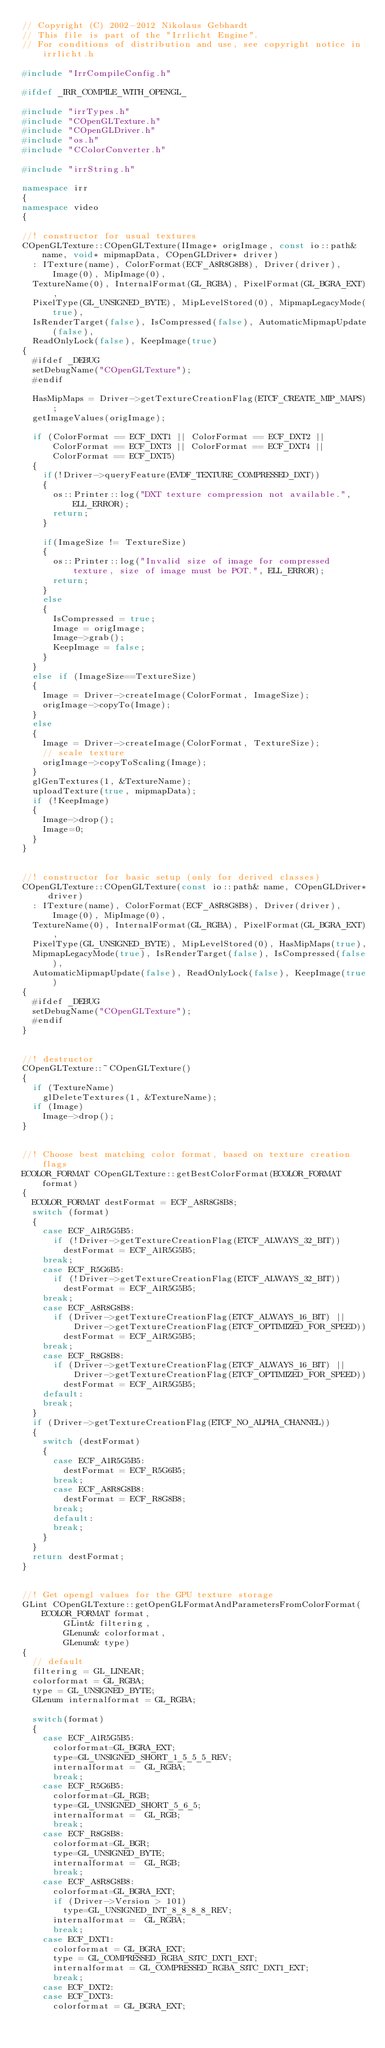<code> <loc_0><loc_0><loc_500><loc_500><_C++_>// Copyright (C) 2002-2012 Nikolaus Gebhardt
// This file is part of the "Irrlicht Engine".
// For conditions of distribution and use, see copyright notice in irrlicht.h

#include "IrrCompileConfig.h"

#ifdef _IRR_COMPILE_WITH_OPENGL_

#include "irrTypes.h"
#include "COpenGLTexture.h"
#include "COpenGLDriver.h"
#include "os.h"
#include "CColorConverter.h"

#include "irrString.h"

namespace irr
{
namespace video
{

//! constructor for usual textures
COpenGLTexture::COpenGLTexture(IImage* origImage, const io::path& name, void* mipmapData, COpenGLDriver* driver)
	: ITexture(name), ColorFormat(ECF_A8R8G8B8), Driver(driver), Image(0), MipImage(0),
	TextureName(0), InternalFormat(GL_RGBA), PixelFormat(GL_BGRA_EXT),
	PixelType(GL_UNSIGNED_BYTE), MipLevelStored(0), MipmapLegacyMode(true),
	IsRenderTarget(false), IsCompressed(false), AutomaticMipmapUpdate(false),
	ReadOnlyLock(false), KeepImage(true)
{
	#ifdef _DEBUG
	setDebugName("COpenGLTexture");
	#endif

	HasMipMaps = Driver->getTextureCreationFlag(ETCF_CREATE_MIP_MAPS);
	getImageValues(origImage);

	if (ColorFormat == ECF_DXT1 || ColorFormat == ECF_DXT2 || ColorFormat == ECF_DXT3 || ColorFormat == ECF_DXT4 || ColorFormat == ECF_DXT5)
	{
		if(!Driver->queryFeature(EVDF_TEXTURE_COMPRESSED_DXT))
		{
			os::Printer::log("DXT texture compression not available.", ELL_ERROR);
			return;
		}

		if(ImageSize != TextureSize)
		{
			os::Printer::log("Invalid size of image for compressed texture, size of image must be POT.", ELL_ERROR);
			return;
		}
		else
		{
			IsCompressed = true;
			Image = origImage;
			Image->grab();
			KeepImage = false;
		}
	}
	else if (ImageSize==TextureSize)
	{
		Image = Driver->createImage(ColorFormat, ImageSize);
		origImage->copyTo(Image);
	}
	else
	{
		Image = Driver->createImage(ColorFormat, TextureSize);
		// scale texture
		origImage->copyToScaling(Image);
	}
	glGenTextures(1, &TextureName);
	uploadTexture(true, mipmapData);
	if (!KeepImage)
	{
		Image->drop();
		Image=0;
	}
}


//! constructor for basic setup (only for derived classes)
COpenGLTexture::COpenGLTexture(const io::path& name, COpenGLDriver* driver)
	: ITexture(name), ColorFormat(ECF_A8R8G8B8), Driver(driver), Image(0), MipImage(0),
	TextureName(0), InternalFormat(GL_RGBA), PixelFormat(GL_BGRA_EXT),
	PixelType(GL_UNSIGNED_BYTE), MipLevelStored(0), HasMipMaps(true),
	MipmapLegacyMode(true), IsRenderTarget(false), IsCompressed(false),
	AutomaticMipmapUpdate(false), ReadOnlyLock(false), KeepImage(true)
{
	#ifdef _DEBUG
	setDebugName("COpenGLTexture");
	#endif
}


//! destructor
COpenGLTexture::~COpenGLTexture()
{
	if (TextureName)
		glDeleteTextures(1, &TextureName);
	if (Image)
		Image->drop();
}


//! Choose best matching color format, based on texture creation flags
ECOLOR_FORMAT COpenGLTexture::getBestColorFormat(ECOLOR_FORMAT format)
{
	ECOLOR_FORMAT destFormat = ECF_A8R8G8B8;
	switch (format)
	{
		case ECF_A1R5G5B5:
			if (!Driver->getTextureCreationFlag(ETCF_ALWAYS_32_BIT))
				destFormat = ECF_A1R5G5B5;
		break;
		case ECF_R5G6B5:
			if (!Driver->getTextureCreationFlag(ETCF_ALWAYS_32_BIT))
				destFormat = ECF_A1R5G5B5;
		break;
		case ECF_A8R8G8B8:
			if (Driver->getTextureCreationFlag(ETCF_ALWAYS_16_BIT) ||
					Driver->getTextureCreationFlag(ETCF_OPTIMIZED_FOR_SPEED))
				destFormat = ECF_A1R5G5B5;
		break;
		case ECF_R8G8B8:
			if (Driver->getTextureCreationFlag(ETCF_ALWAYS_16_BIT) ||
					Driver->getTextureCreationFlag(ETCF_OPTIMIZED_FOR_SPEED))
				destFormat = ECF_A1R5G5B5;
		default:
		break;
	}
	if (Driver->getTextureCreationFlag(ETCF_NO_ALPHA_CHANNEL))
	{
		switch (destFormat)
		{
			case ECF_A1R5G5B5:
				destFormat = ECF_R5G6B5;
			break;
			case ECF_A8R8G8B8:
				destFormat = ECF_R8G8B8;
			break;
			default:
			break;
		}
	}
	return destFormat;
}


//! Get opengl values for the GPU texture storage
GLint COpenGLTexture::getOpenGLFormatAndParametersFromColorFormat(ECOLOR_FORMAT format,
				GLint& filtering,
				GLenum& colorformat,
				GLenum& type)
{
	// default
	filtering = GL_LINEAR;
	colorformat = GL_RGBA;
	type = GL_UNSIGNED_BYTE;
	GLenum internalformat = GL_RGBA;

	switch(format)
	{
		case ECF_A1R5G5B5:
			colorformat=GL_BGRA_EXT;
			type=GL_UNSIGNED_SHORT_1_5_5_5_REV;
			internalformat =  GL_RGBA;
			break;
		case ECF_R5G6B5:
			colorformat=GL_RGB;
			type=GL_UNSIGNED_SHORT_5_6_5;
			internalformat =  GL_RGB;
			break;
		case ECF_R8G8B8:
			colorformat=GL_BGR;
			type=GL_UNSIGNED_BYTE;
			internalformat =  GL_RGB;
			break;
		case ECF_A8R8G8B8:
			colorformat=GL_BGRA_EXT;
			if (Driver->Version > 101)
				type=GL_UNSIGNED_INT_8_8_8_8_REV;
			internalformat =  GL_RGBA;
			break;
		case ECF_DXT1:
			colorformat = GL_BGRA_EXT;
			type = GL_COMPRESSED_RGBA_S3TC_DXT1_EXT;
			internalformat = GL_COMPRESSED_RGBA_S3TC_DXT1_EXT;
			break;
		case ECF_DXT2:
		case ECF_DXT3:
			colorformat = GL_BGRA_EXT;</code> 